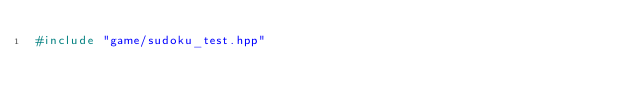<code> <loc_0><loc_0><loc_500><loc_500><_C++_>#include "game/sudoku_test.hpp"
</code> 